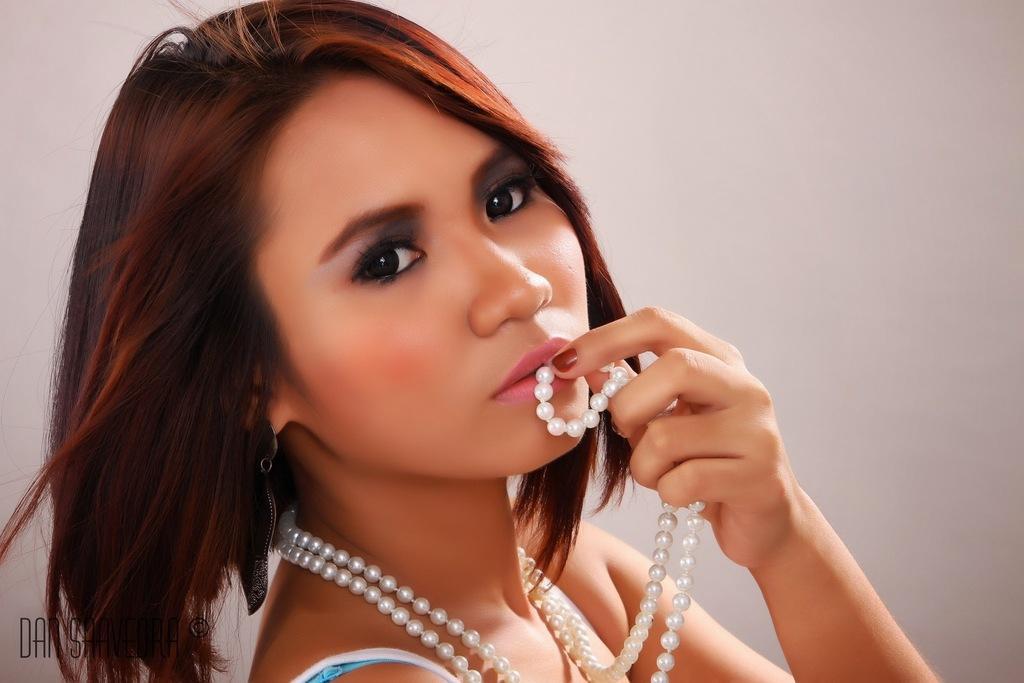Can you describe this image briefly? In this image we can see a woman holding the pearl chain. In the background we can see the plain wall. In the bottom left corner there is text. 